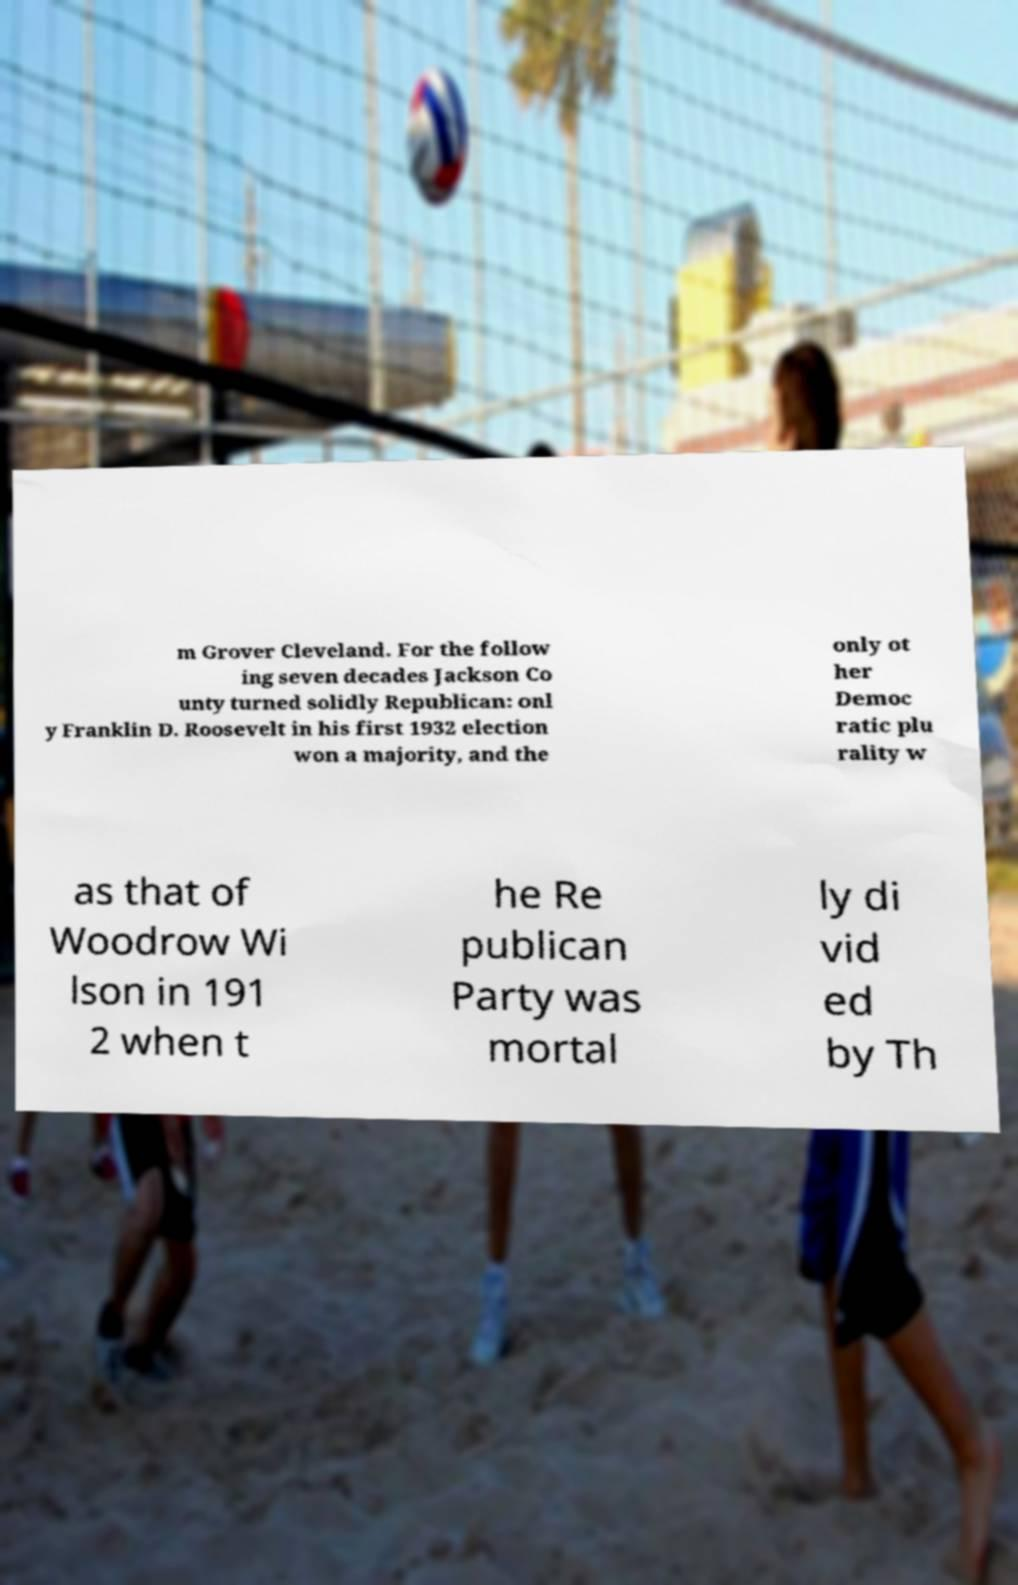What messages or text are displayed in this image? I need them in a readable, typed format. m Grover Cleveland. For the follow ing seven decades Jackson Co unty turned solidly Republican: onl y Franklin D. Roosevelt in his first 1932 election won a majority, and the only ot her Democ ratic plu rality w as that of Woodrow Wi lson in 191 2 when t he Re publican Party was mortal ly di vid ed by Th 